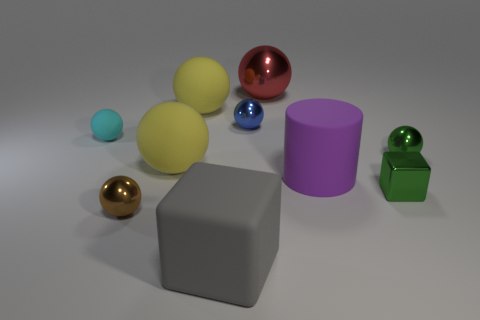Subtract 3 spheres. How many spheres are left? 4 Subtract all red spheres. How many spheres are left? 6 Subtract all small shiny spheres. How many spheres are left? 4 Subtract all green spheres. Subtract all yellow blocks. How many spheres are left? 6 Subtract all cylinders. How many objects are left? 9 Add 9 tiny purple balls. How many tiny purple balls exist? 9 Subtract 2 yellow spheres. How many objects are left? 8 Subtract all tiny blue spheres. Subtract all tiny red matte blocks. How many objects are left? 9 Add 8 green cubes. How many green cubes are left? 9 